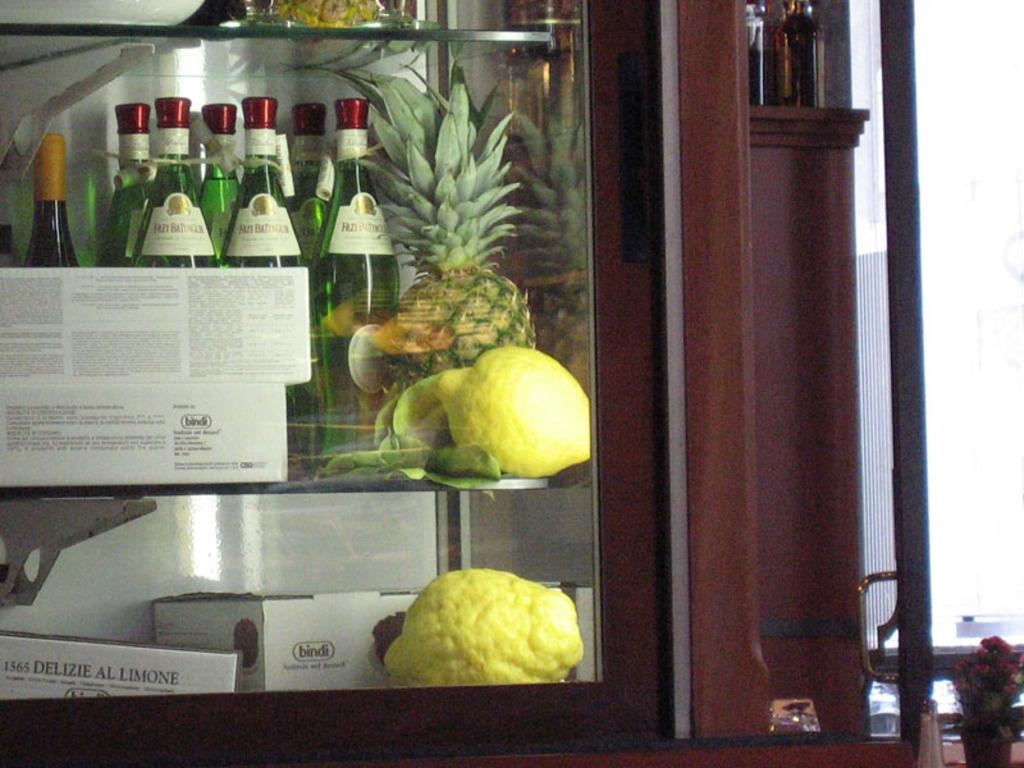What type of food items can be seen in the image? There are fruits in the image. What else can be seen in the image besides the fruits? There are bottles and boxes on a glass shelf visible in the image. What is the material of the shelf in the image? The shelf is made of glass. What is the wooden object in the image used for? The wooden object resembles a cupboard, which is typically used for storage. Can you tell me what the queen is doing in the image? There is no queen present in the image. What type of drum can be seen in the image? There is no drum present in the image. 